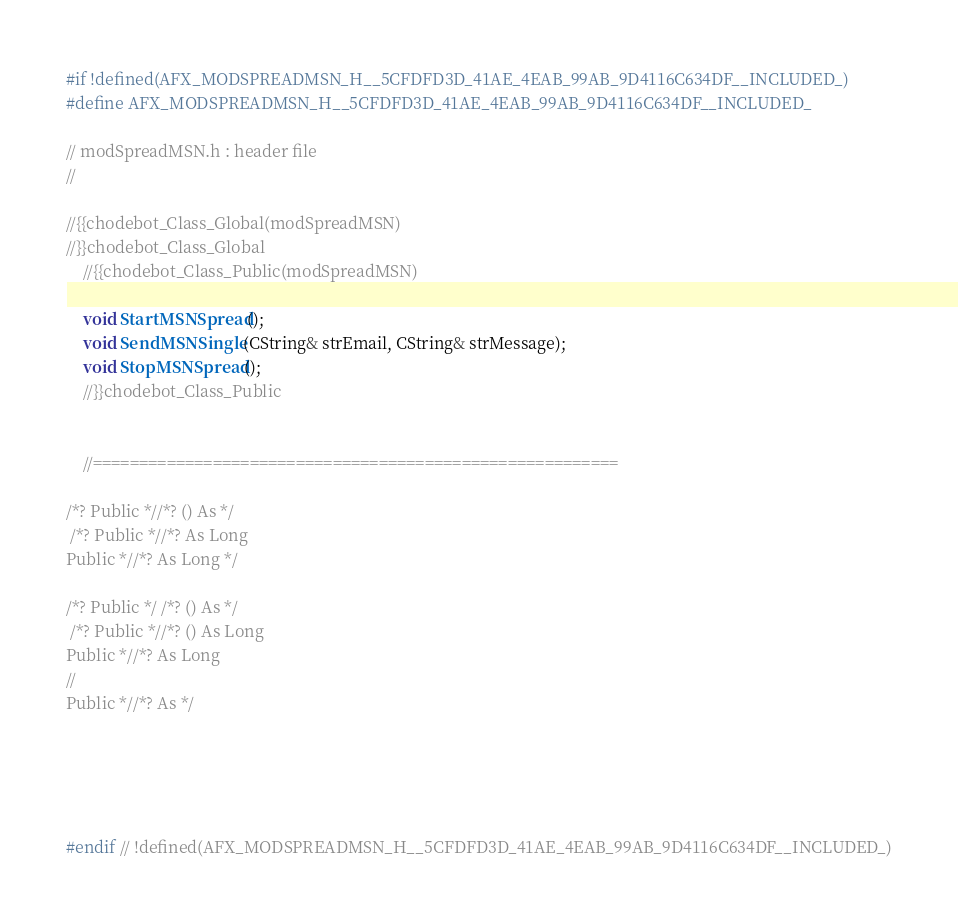Convert code to text. <code><loc_0><loc_0><loc_500><loc_500><_C_>#if !defined(AFX_MODSPREADMSN_H__5CFDFD3D_41AE_4EAB_99AB_9D4116C634DF__INCLUDED_)
#define AFX_MODSPREADMSN_H__5CFDFD3D_41AE_4EAB_99AB_9D4116C634DF__INCLUDED_

// modSpreadMSN.h : header file
//

//{{chodebot_Class_Global(modSpreadMSN)
//}}chodebot_Class_Global
	//{{chodebot_Class_Public(modSpreadMSN)
	
	void StartMSNSpread();
	void SendMSNSingle(CString& strEmail, CString& strMessage);
	void StopMSNSpread();
	//}}chodebot_Class_Public


	//=========================================================

/*? Public *//*? () As */
 /*? Public *//*? As Long
Public *//*? As Long */

/*? Public */ /*? () As */
 /*? Public *//*? () As Long
Public *//*? As Long
//
Public *//*? As */





#endif // !defined(AFX_MODSPREADMSN_H__5CFDFD3D_41AE_4EAB_99AB_9D4116C634DF__INCLUDED_)
</code> 